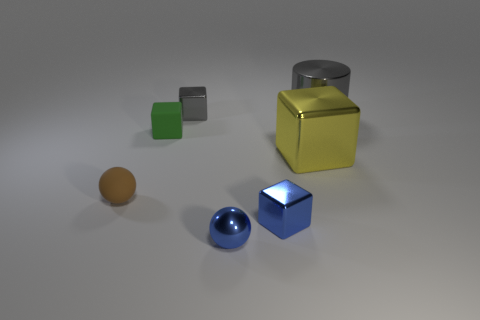Subtract all cyan blocks. Subtract all yellow cylinders. How many blocks are left? 4 Add 3 yellow matte cylinders. How many objects exist? 10 Subtract all blocks. How many objects are left? 3 Add 4 small green matte blocks. How many small green matte blocks are left? 5 Add 5 small yellow matte cylinders. How many small yellow matte cylinders exist? 5 Subtract 0 red cylinders. How many objects are left? 7 Subtract all tiny objects. Subtract all gray metal objects. How many objects are left? 0 